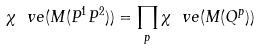<formula> <loc_0><loc_0><loc_500><loc_500>\chi _ { \ } v e ( M ( P ^ { 1 } P ^ { 2 } ) ) = \prod _ { p } \chi _ { \ } v e ( M ( Q ^ { p } ) )</formula> 